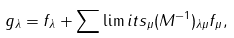Convert formula to latex. <formula><loc_0><loc_0><loc_500><loc_500>g _ { \lambda } = f _ { \lambda } + \sum \lim i t s _ { \mu } ( M ^ { - 1 } ) _ { \lambda \mu } f _ { \mu } ,</formula> 